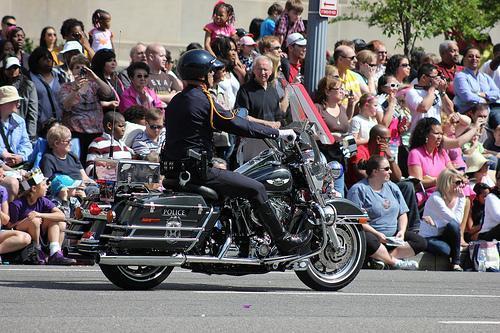How many police officers are there?
Give a very brief answer. 1. 